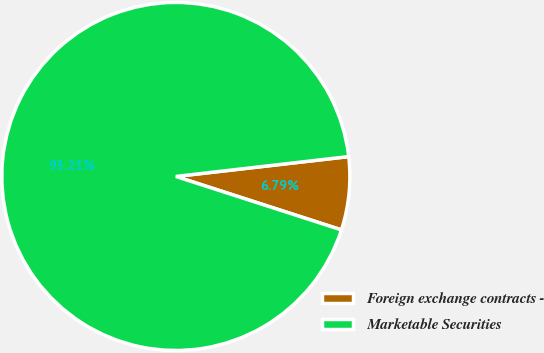<chart> <loc_0><loc_0><loc_500><loc_500><pie_chart><fcel>Foreign exchange contracts -<fcel>Marketable Securities<nl><fcel>6.79%<fcel>93.21%<nl></chart> 